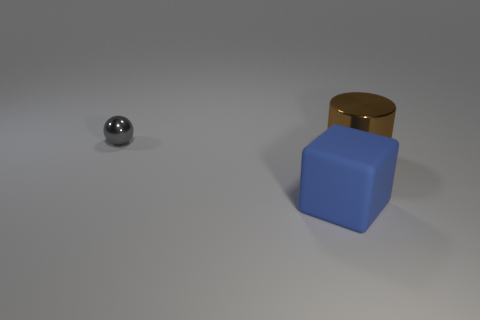Add 1 large cylinders. How many objects exist? 4 Subtract all cylinders. How many objects are left? 2 Subtract all tiny objects. Subtract all small spheres. How many objects are left? 1 Add 2 brown cylinders. How many brown cylinders are left? 3 Add 1 cylinders. How many cylinders exist? 2 Subtract 0 brown spheres. How many objects are left? 3 